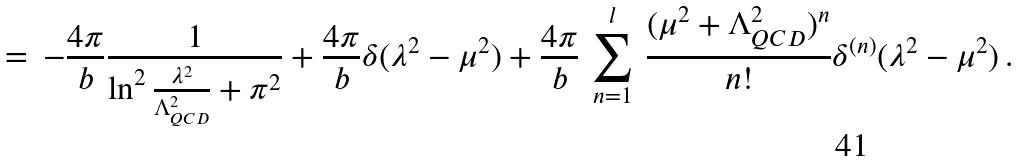<formula> <loc_0><loc_0><loc_500><loc_500>= \, - \frac { 4 \pi } { b } \frac { 1 } { \ln ^ { 2 } { \frac { \lambda ^ { 2 } } { \Lambda _ { Q C D } ^ { 2 } } } + \pi ^ { 2 } } + \frac { 4 \pi } { b } \delta ( \lambda ^ { 2 } - \mu ^ { 2 } ) + \frac { 4 \pi } { b } \, \sum _ { n = 1 } ^ { l } \, \frac { ( \mu ^ { 2 } + \Lambda _ { Q C D } ^ { 2 } ) ^ { n } } { n ! } \delta ^ { ( n ) } ( \lambda ^ { 2 } - \mu ^ { 2 } ) \, .</formula> 